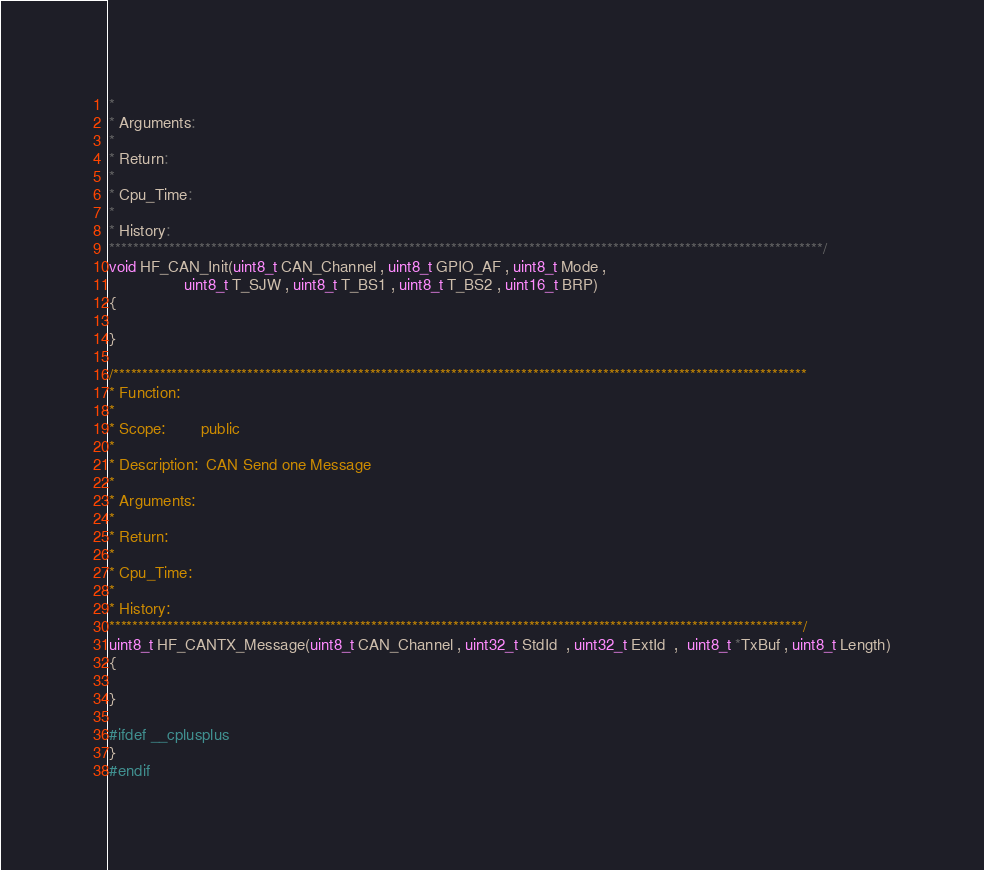<code> <loc_0><loc_0><loc_500><loc_500><_C_>*
* Arguments:
*
* Return:
*
* Cpu_Time:
*
* History:
***********************************************************************************************************************/
void HF_CAN_Init(uint8_t CAN_Channel , uint8_t GPIO_AF , uint8_t Mode ,
                 uint8_t T_SJW , uint8_t T_BS1 , uint8_t T_BS2 , uint16_t BRP)
{

}

/***********************************************************************************************************************
* Function:
*
* Scope:        public
*
* Description:  CAN Send one Message
*
* Arguments:
*
* Return:
*
* Cpu_Time:
*
* History:
***********************************************************************************************************************/
uint8_t HF_CANTX_Message(uint8_t CAN_Channel , uint32_t StdId  , uint32_t ExtId  ,  uint8_t *TxBuf , uint8_t Length)
{

}

#ifdef __cplusplus
}
#endif
</code> 